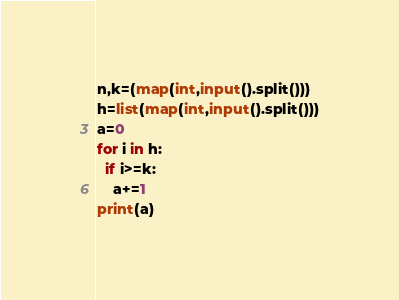Convert code to text. <code><loc_0><loc_0><loc_500><loc_500><_Python_>n,k=(map(int,input().split()))
h=list(map(int,input().split()))
a=0
for i in h:
  if i>=k:
    a+=1
print(a)</code> 